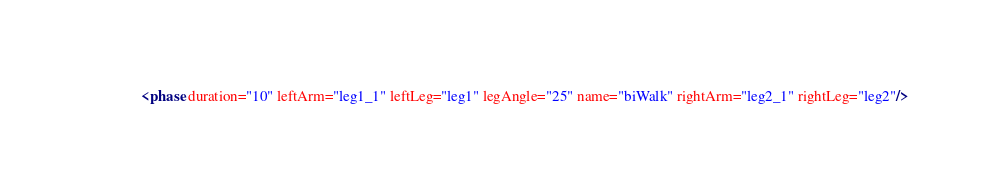<code> <loc_0><loc_0><loc_500><loc_500><_XML_>  <phase duration="10" leftArm="leg1_1" leftLeg="leg1" legAngle="25" name="biWalk" rightArm="leg2_1" rightLeg="leg2"/></code> 